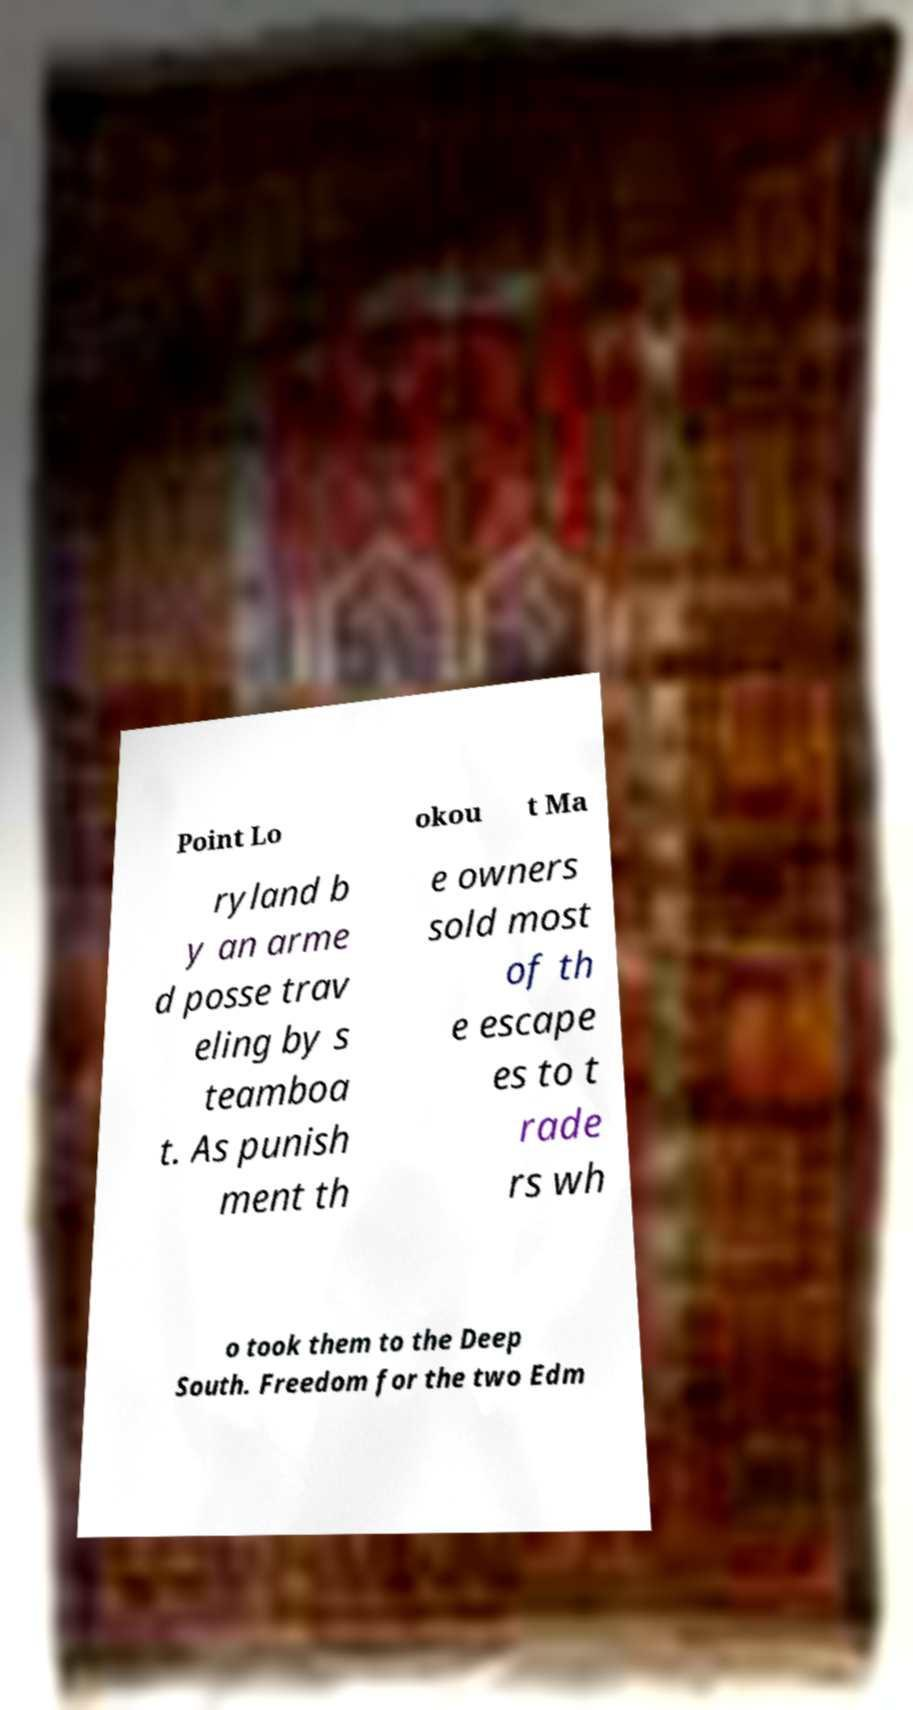Could you extract and type out the text from this image? Point Lo okou t Ma ryland b y an arme d posse trav eling by s teamboa t. As punish ment th e owners sold most of th e escape es to t rade rs wh o took them to the Deep South. Freedom for the two Edm 